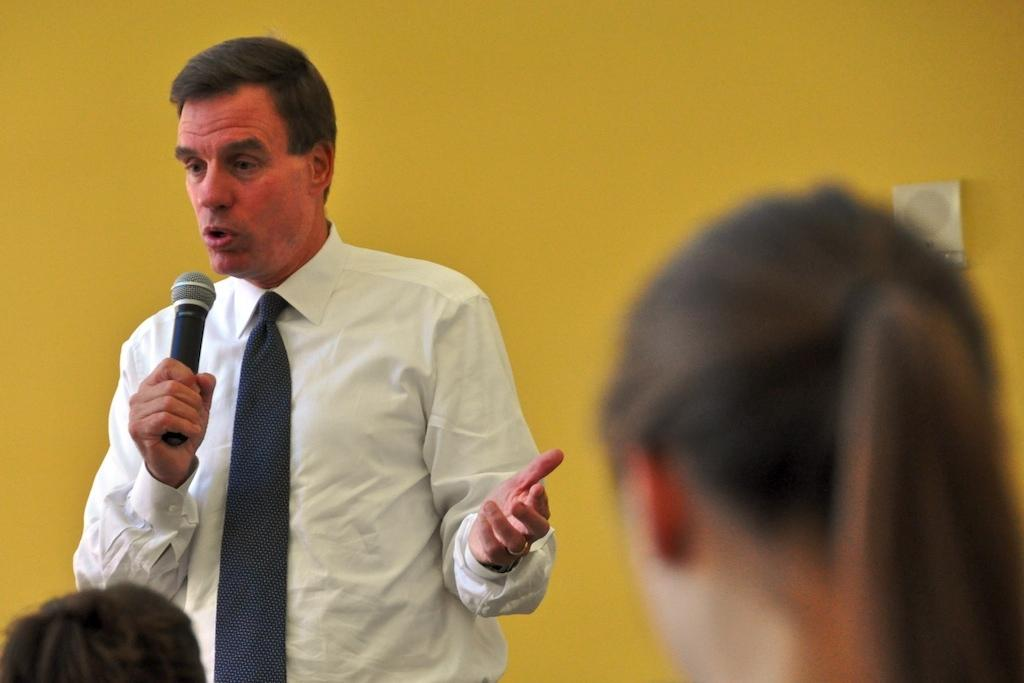What is the person in the image doing? The person is standing and holding a microphone. How many other people are in the image? There are two other persons in the image. What can be seen in the background of the image? There is a wall visible in the background of the image. What type of texture can be seen on the lamp in the image? There is no lamp present in the image. What role does the judge play in the image? There is no judge present in the image. 